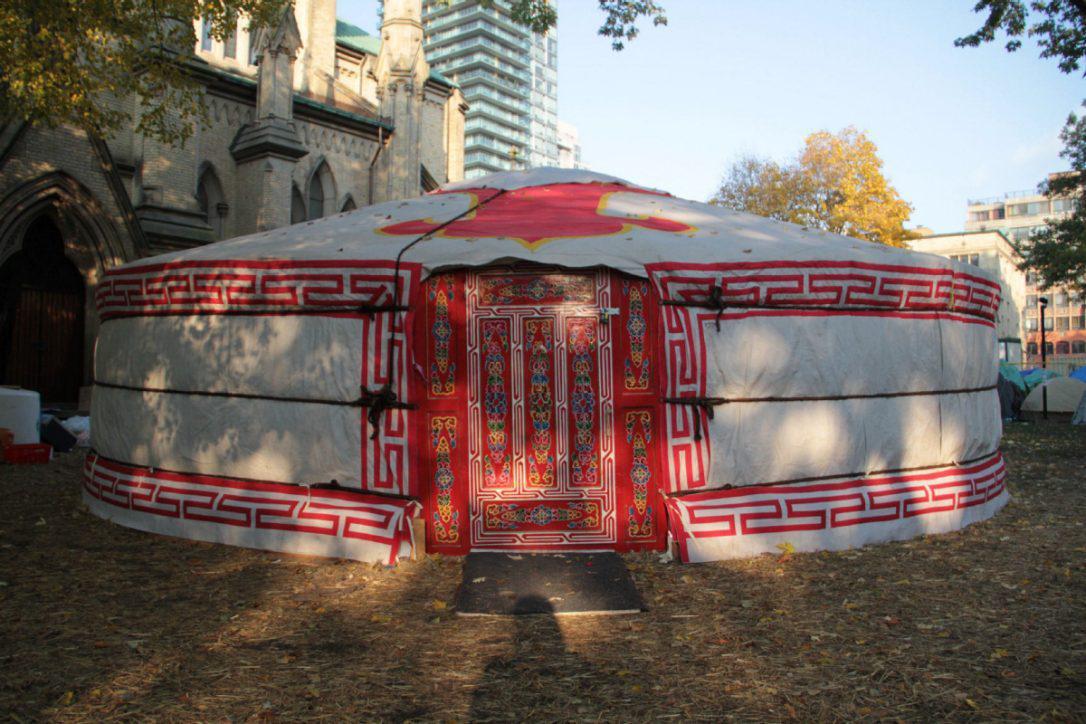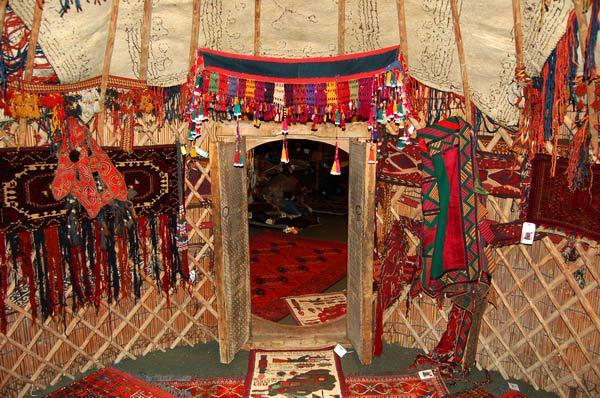The first image is the image on the left, the second image is the image on the right. Analyze the images presented: Is the assertion "The right image contains at least one human being." valid? Answer yes or no. No. The first image is the image on the left, the second image is the image on the right. Evaluate the accuracy of this statement regarding the images: "One image shows the interior of a yurt with at least two support beams and latticed walls, with a light fixture hanging from the center of the ceiling.". Is it true? Answer yes or no. No. 